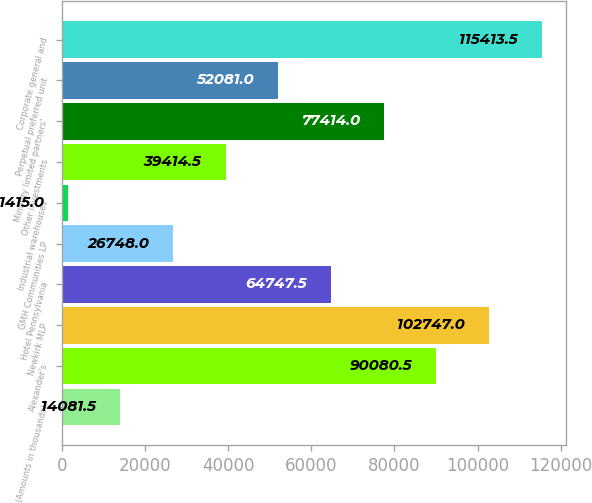<chart> <loc_0><loc_0><loc_500><loc_500><bar_chart><fcel>(Amounts in thousands)<fcel>Alexander's<fcel>Newkirk MLP<fcel>Hotel Pennsylvania<fcel>GMH Communities LP<fcel>Industrial warehouses<fcel>Other investments<fcel>Minority limited partners'<fcel>Perpetual preferred unit<fcel>Corporate general and<nl><fcel>14081.5<fcel>90080.5<fcel>102747<fcel>64747.5<fcel>26748<fcel>1415<fcel>39414.5<fcel>77414<fcel>52081<fcel>115414<nl></chart> 